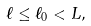<formula> <loc_0><loc_0><loc_500><loc_500>\ell \leq \ell _ { 0 } < L ,</formula> 